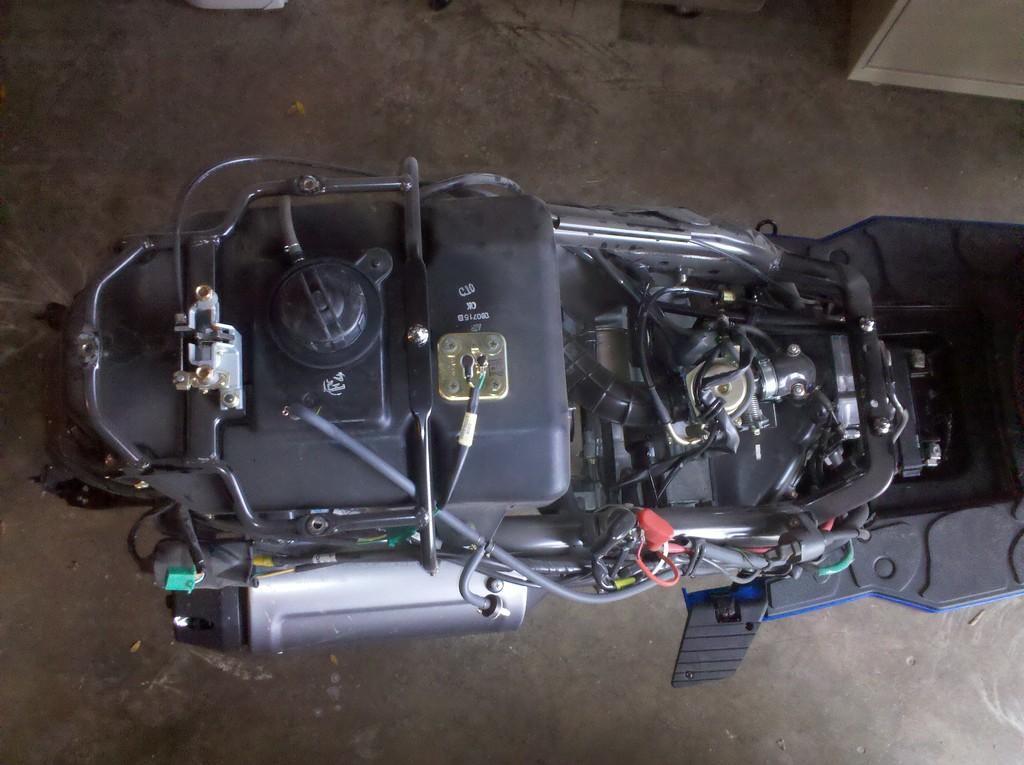Could you give a brief overview of what you see in this image? In the image we can see there is an engine of the bike. 